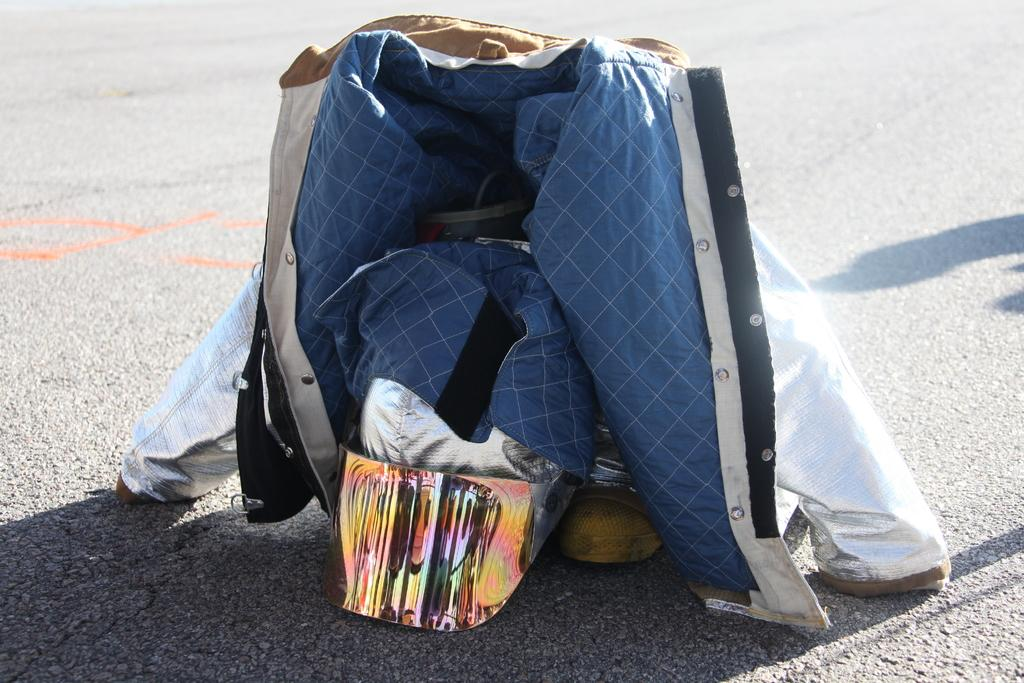What type of clothing item is visible in the image? There is a jacket in the image. What can be seen on the road in the image? There are objects on the road in the image. What sense is being used to experience the glue in the image? There is no glue present in the image, so it cannot be experienced using any sense. 